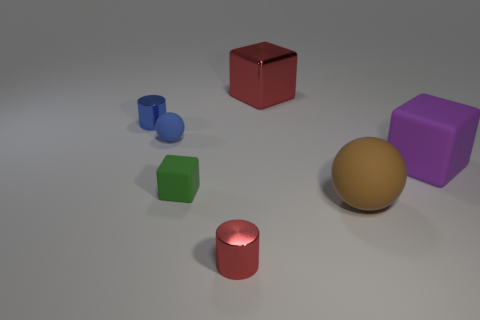There is a small cylinder in front of the brown ball; what color is it?
Make the answer very short. Red. Do the red cylinder and the red thing that is behind the green rubber block have the same size?
Provide a short and direct response. No. How big is the block that is both left of the big brown rubber thing and in front of the small matte sphere?
Provide a short and direct response. Small. Are there any brown spheres made of the same material as the big brown object?
Your answer should be very brief. No. What is the shape of the big metallic thing?
Make the answer very short. Cube. Does the brown matte ball have the same size as the green cube?
Make the answer very short. No. What number of other objects are the same shape as the big brown matte object?
Your answer should be very brief. 1. What shape is the red metallic object in front of the brown rubber ball?
Give a very brief answer. Cylinder. Does the red object that is left of the metal cube have the same shape as the small metal object behind the large brown thing?
Make the answer very short. Yes. Are there an equal number of metallic cubes behind the green rubber cube and small blue matte objects?
Your answer should be compact. Yes. 